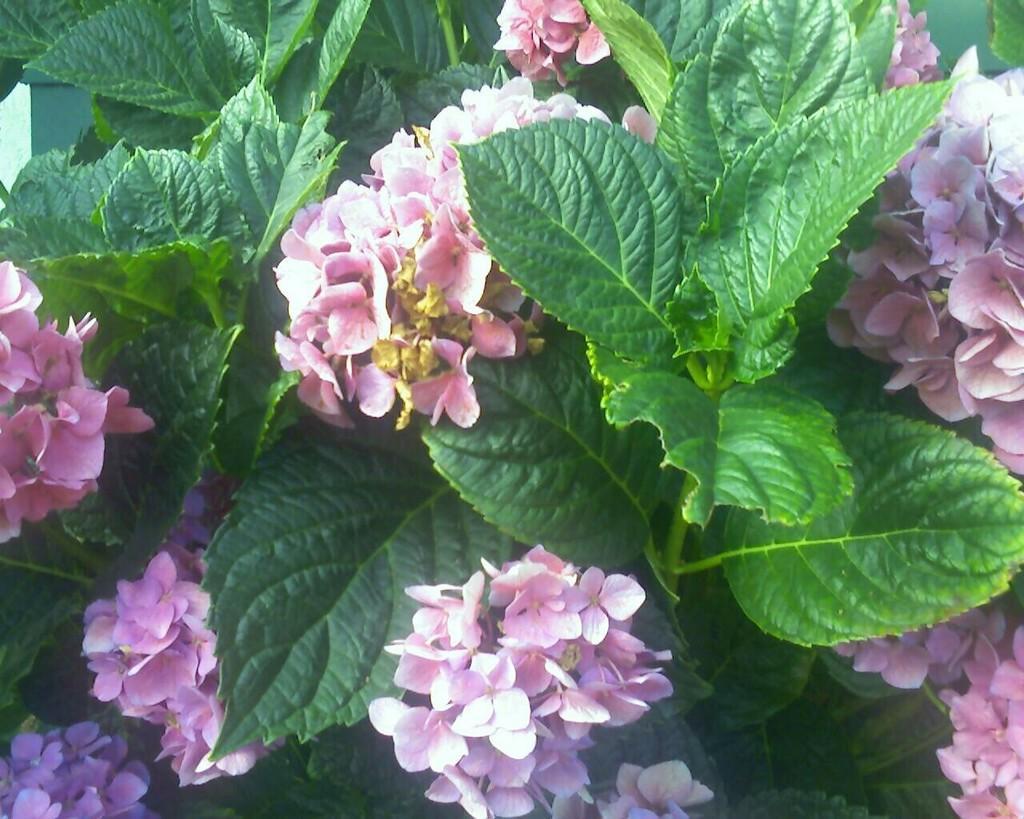Please provide a concise description of this image. In this image there are few plants having flowers and leaves. 